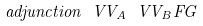Convert formula to latex. <formula><loc_0><loc_0><loc_500><loc_500>\ a d j u n c t i o n { \ V V _ { A } } { \ V V _ { B } } F G</formula> 